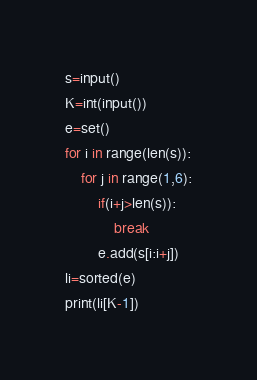Convert code to text. <code><loc_0><loc_0><loc_500><loc_500><_Python_>s=input()
K=int(input())
e=set()
for i in range(len(s)):
    for j in range(1,6):
        if(i+j>len(s)):
            break
        e.add(s[i:i+j])
li=sorted(e)
print(li[K-1])</code> 